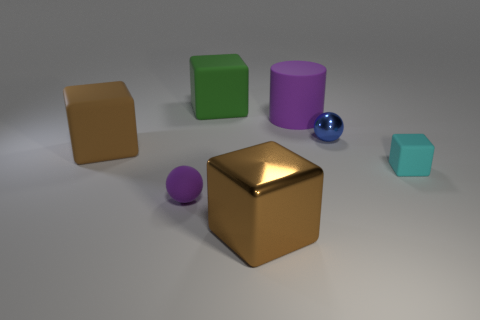What size is the green matte block?
Provide a short and direct response. Large. Are there fewer big purple matte cylinders in front of the big purple thing than tiny green matte blocks?
Offer a very short reply. No. Do the blue ball and the purple thing that is to the right of the green rubber cube have the same material?
Your answer should be very brief. No. There is a purple object that is behind the small thing that is on the right side of the blue thing; is there a matte cube that is behind it?
Your answer should be very brief. Yes. Is there anything else that has the same size as the brown matte thing?
Your answer should be compact. Yes. What color is the thing that is made of the same material as the tiny blue sphere?
Give a very brief answer. Brown. There is a thing that is both on the left side of the brown shiny thing and behind the big brown matte block; what size is it?
Keep it short and to the point. Large. Are there fewer brown metal blocks behind the large green object than big brown cubes on the right side of the small cyan matte cube?
Your answer should be compact. No. Does the big object right of the brown shiny object have the same material as the tiny purple ball that is on the left side of the green cube?
Give a very brief answer. Yes. What is the shape of the rubber thing that is both in front of the green object and behind the brown rubber cube?
Ensure brevity in your answer.  Cylinder. 